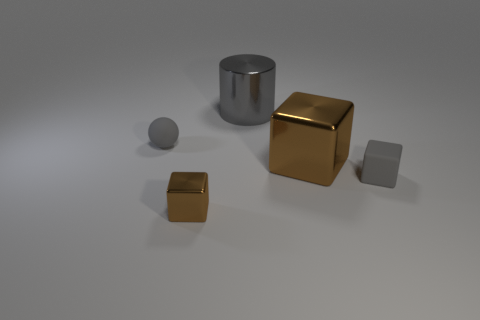Add 5 big gray objects. How many objects exist? 10 Subtract all blocks. How many objects are left? 2 Add 2 gray things. How many gray things are left? 5 Add 2 metallic cubes. How many metallic cubes exist? 4 Subtract 1 gray cubes. How many objects are left? 4 Subtract all small green matte cylinders. Subtract all tiny brown blocks. How many objects are left? 4 